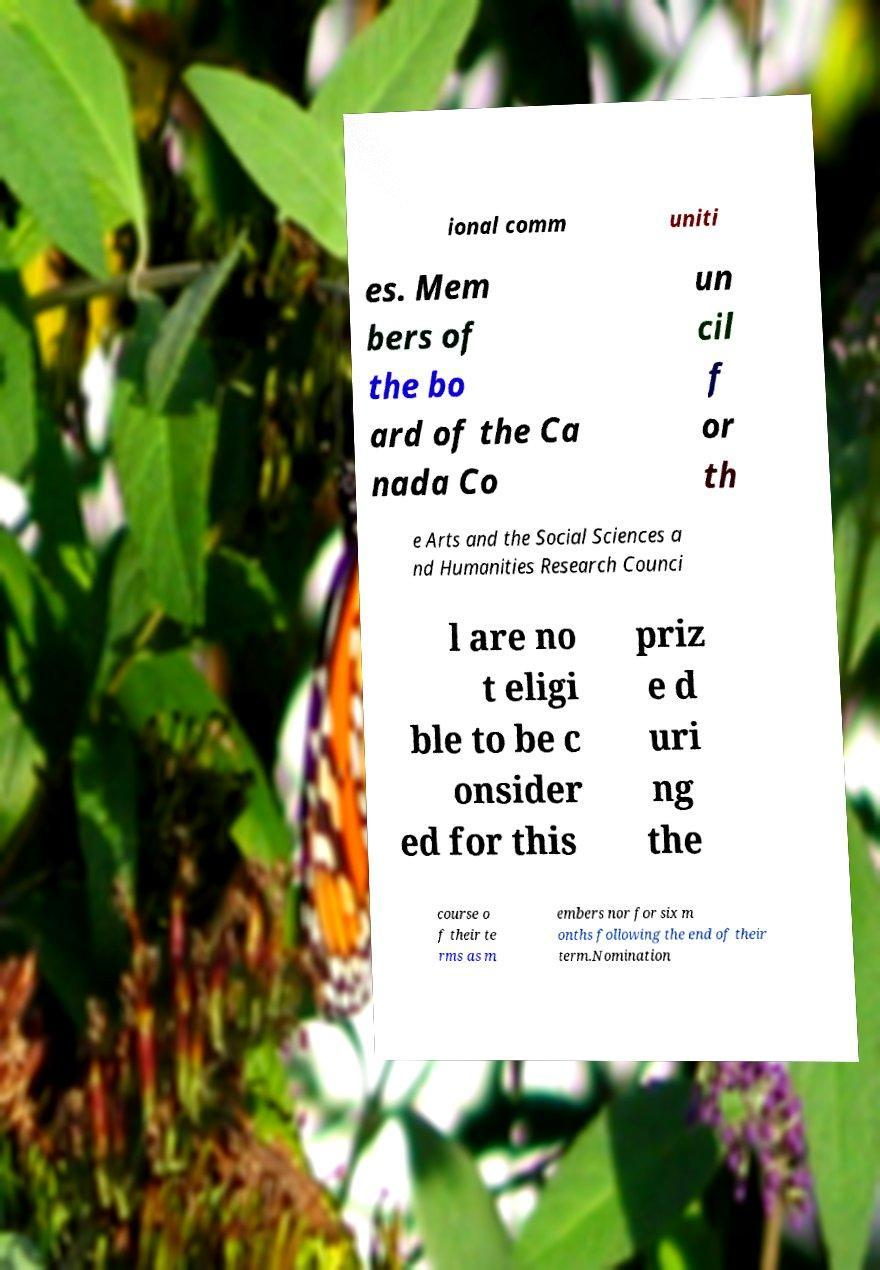Can you read and provide the text displayed in the image?This photo seems to have some interesting text. Can you extract and type it out for me? ional comm uniti es. Mem bers of the bo ard of the Ca nada Co un cil f or th e Arts and the Social Sciences a nd Humanities Research Counci l are no t eligi ble to be c onsider ed for this priz e d uri ng the course o f their te rms as m embers nor for six m onths following the end of their term.Nomination 